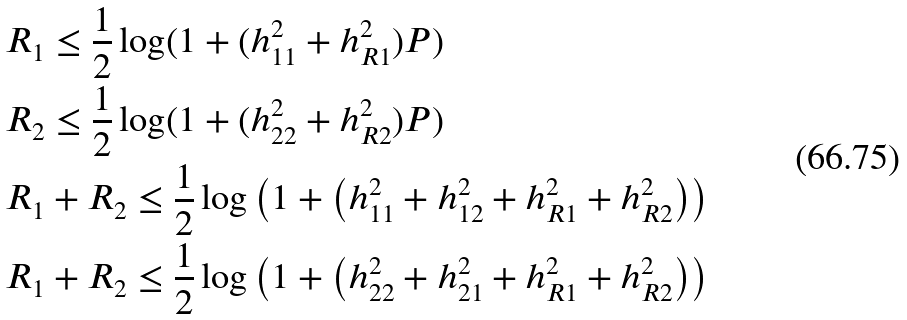Convert formula to latex. <formula><loc_0><loc_0><loc_500><loc_500>& R _ { 1 } \leq \frac { 1 } { 2 } \log ( 1 + ( h _ { 1 1 } ^ { 2 } + h _ { R 1 } ^ { 2 } ) P ) \\ & R _ { 2 } \leq \frac { 1 } { 2 } \log ( 1 + ( h _ { 2 2 } ^ { 2 } + h _ { R 2 } ^ { 2 } ) P ) \\ & R _ { 1 } + R _ { 2 } \leq \frac { 1 } { 2 } \log \left ( 1 + \left ( h _ { 1 1 } ^ { 2 } + h _ { 1 2 } ^ { 2 } + h _ { R 1 } ^ { 2 } + h _ { R 2 } ^ { 2 } \right ) \right ) \\ & R _ { 1 } + R _ { 2 } \leq \frac { 1 } { 2 } \log \left ( 1 + \left ( h _ { 2 2 } ^ { 2 } + h _ { 2 1 } ^ { 2 } + h _ { R 1 } ^ { 2 } + h _ { R 2 } ^ { 2 } \right ) \right )</formula> 